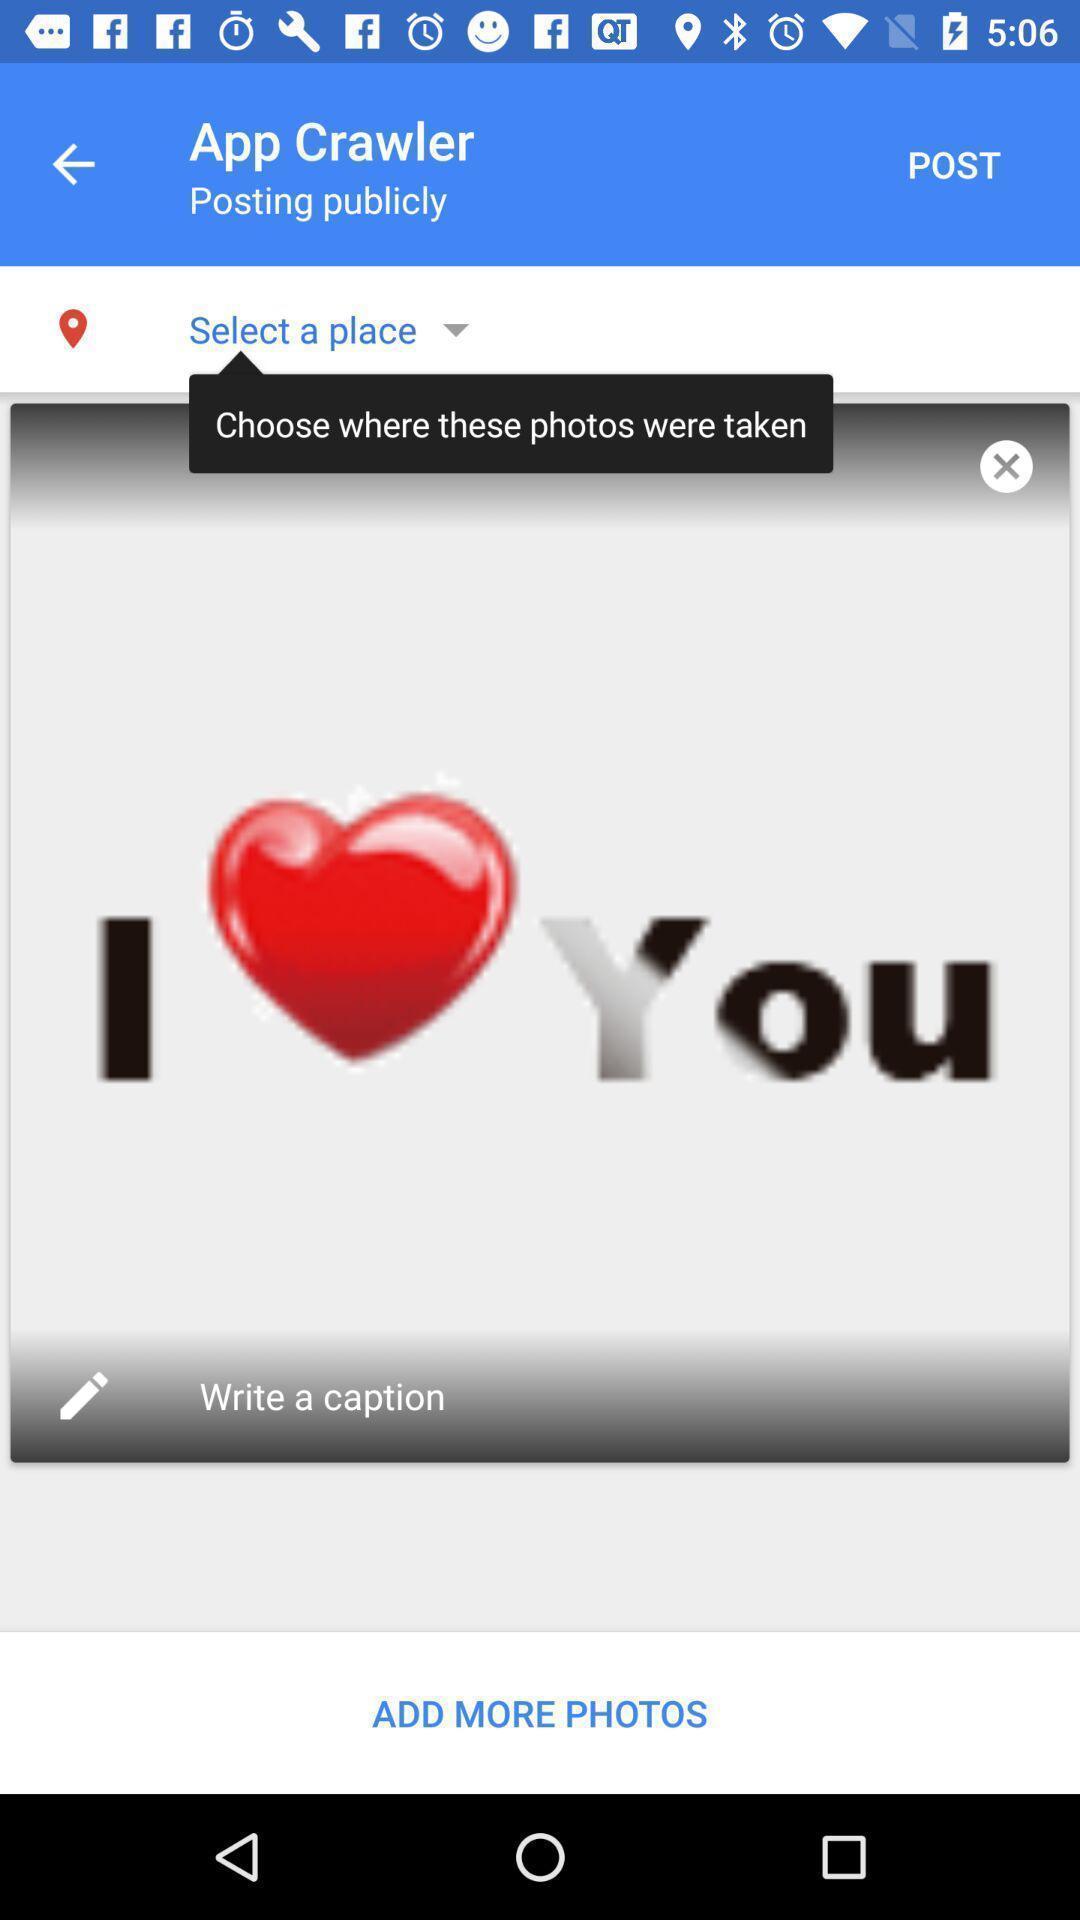Provide a detailed account of this screenshot. Sticker posting page in a emoji app. 